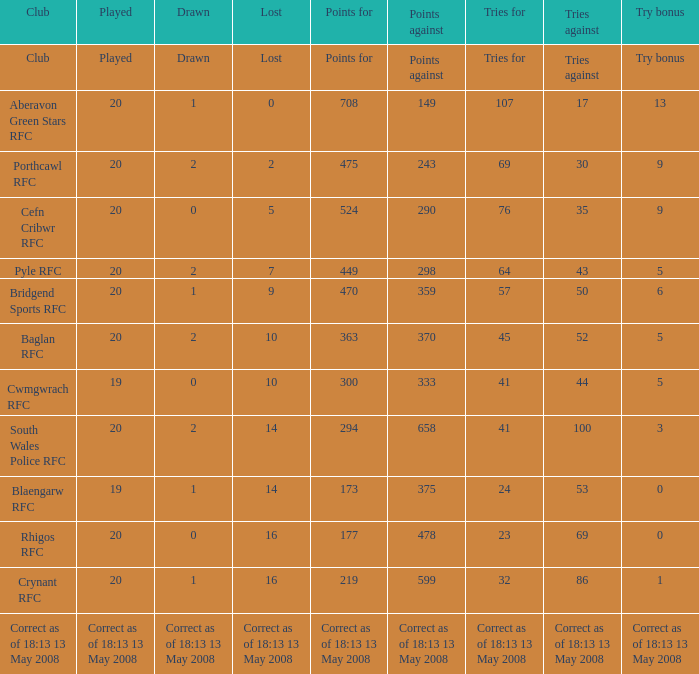When 20 games have been played and none are lost, what is the points tally? 708.0. 